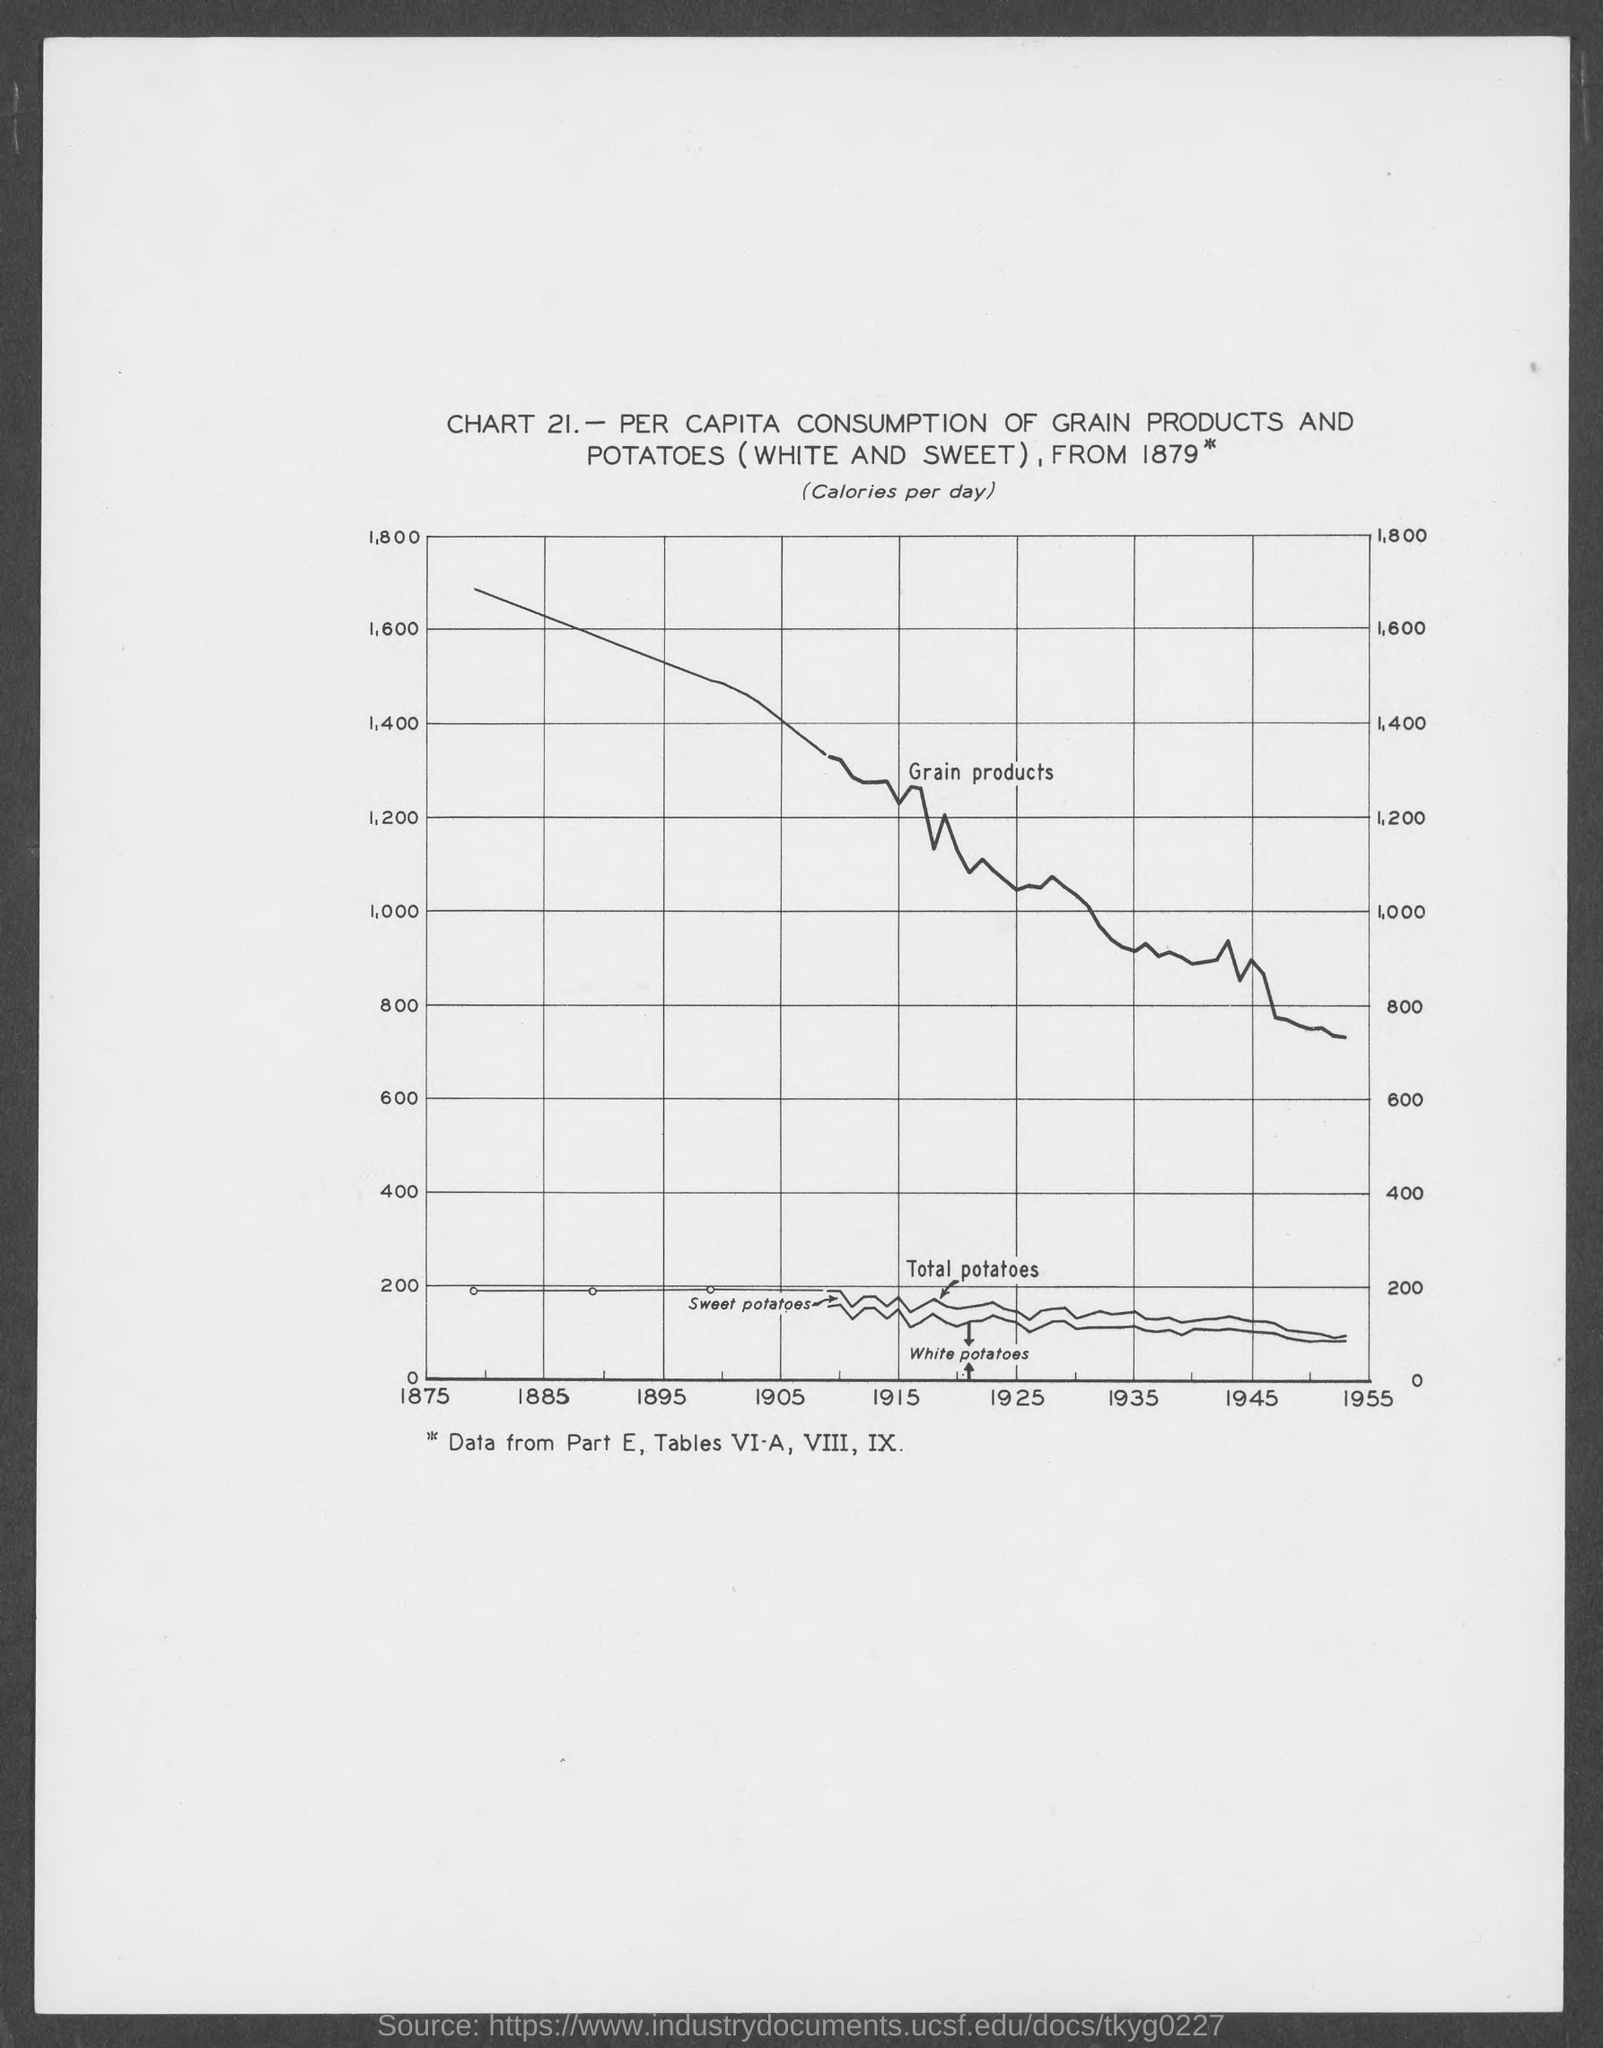Outline some significant characteristics in this image. The chart number is 21. 